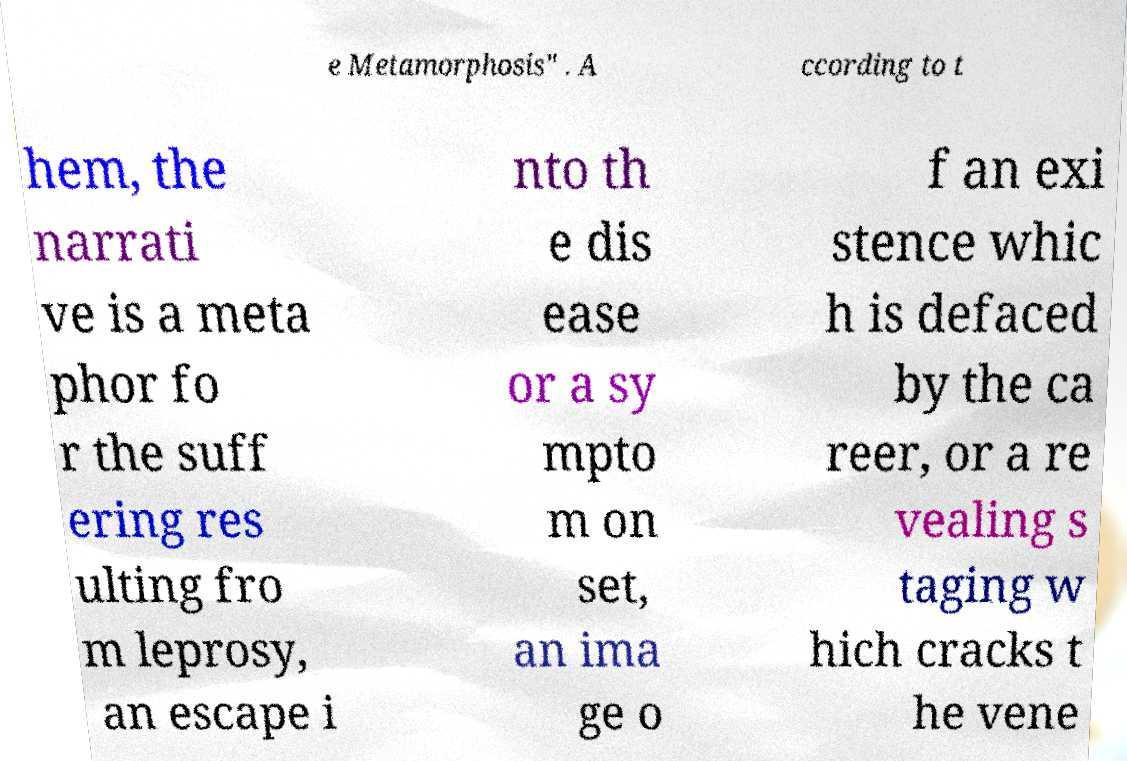Can you accurately transcribe the text from the provided image for me? e Metamorphosis" . A ccording to t hem, the narrati ve is a meta phor fo r the suff ering res ulting fro m leprosy, an escape i nto th e dis ease or a sy mpto m on set, an ima ge o f an exi stence whic h is defaced by the ca reer, or a re vealing s taging w hich cracks t he vene 